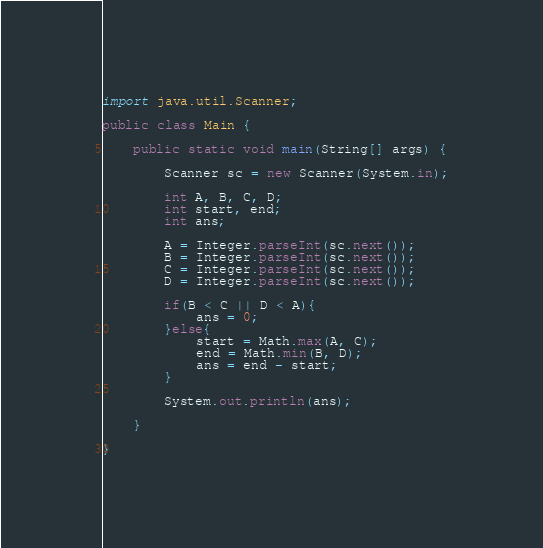Convert code to text. <code><loc_0><loc_0><loc_500><loc_500><_Java_>import java.util.Scanner;

public class Main {

	public static void main(String[] args) {

		Scanner sc = new Scanner(System.in);

		int A, B, C, D;
		int start, end;
		int ans;

		A = Integer.parseInt(sc.next());
		B = Integer.parseInt(sc.next());
		C = Integer.parseInt(sc.next());
		D = Integer.parseInt(sc.next());

		if(B < C || D < A){
			ans = 0;
		}else{
			start = Math.max(A, C);
			end = Math.min(B, D);
			ans = end - start;
		}

		System.out.println(ans);

	}

}</code> 